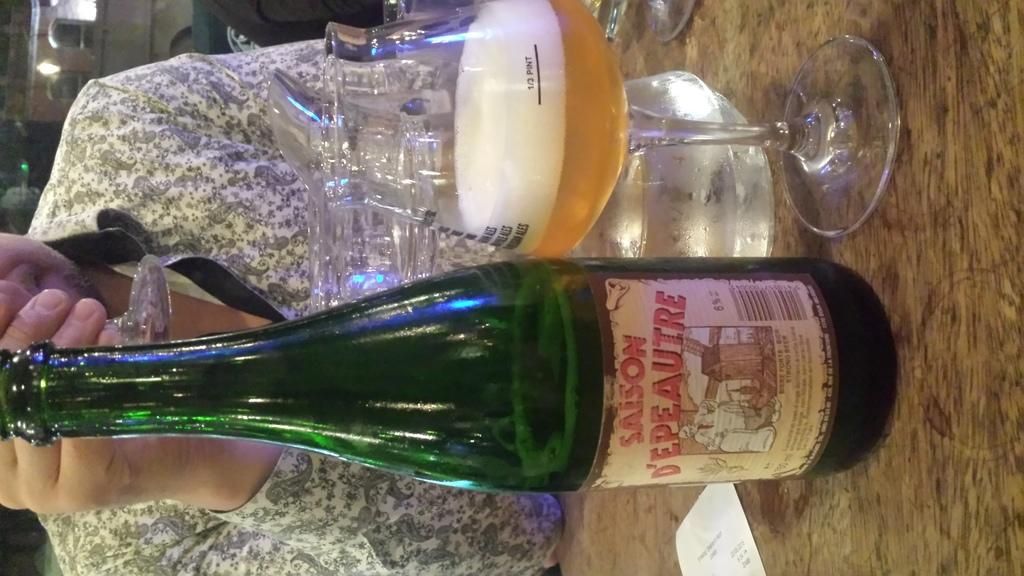<image>
Offer a succinct explanation of the picture presented. the word saison that is on a bottle 